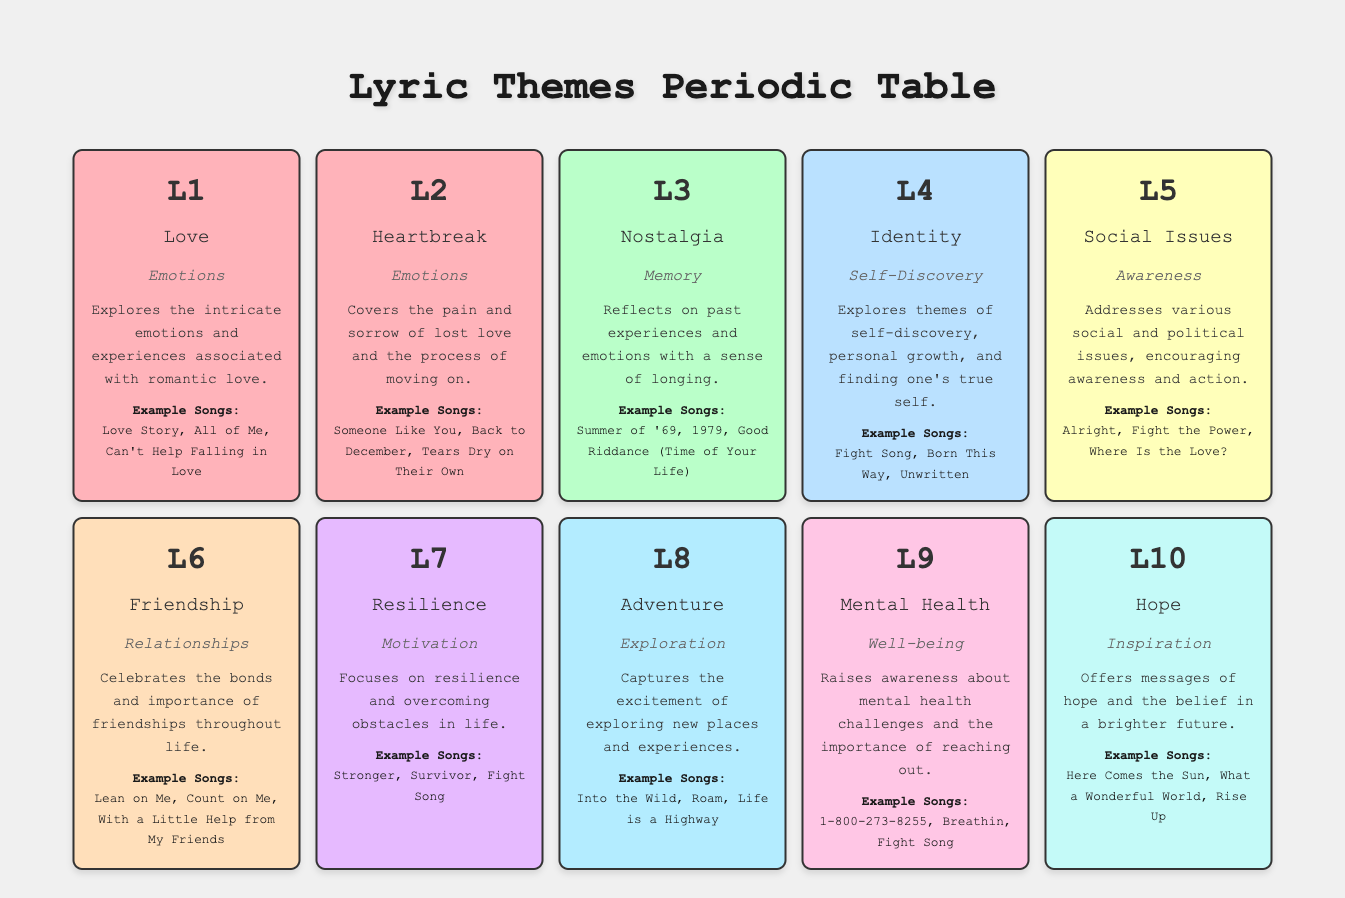What are the example songs for the theme of Identity? The table lists "Fight Song," "Born This Way," and "Unwritten" as example songs for the theme of Identity.
Answer: Fight Song, Born This Way, Unwritten Which theme addresses the pain of lost love? The theme of Heartbreak, as described in the table, specifically covers the pain and sorrow of lost love.
Answer: Heartbreak How many themes are related to emotions? There are two themes related to emotions: Love and Heartbreak, making a total of 2.
Answer: 2 Is "Lean on Me" part of the theme of Friendship? Yes, according to the table, "Lean on Me" is listed under the Friendship theme.
Answer: Yes List the example songs for the Resilience theme. The table states that the example songs for Resilience are "Stronger," "Survivor," and "Fight Song."
Answer: Stronger, Survivor, Fight Song Which themes belong to the category of Self-Discovery? The only theme categorized under Self-Discovery in the table is Identity.
Answer: Identity What is the main focus of the theme of Adventure? The Adventure theme focuses on capturing the excitement of exploring new places and experiences.
Answer: Exploring new places and experiences If you combine the example songs from both Love and Heartbreak, how many unique songs are there? The example songs for Love are "Love Story," "All of Me," "Can't Help Falling in Love," while for Heartbreak, they are "Someone Like You," "Back to December," and "Tears Dry on Their Own." Listing them gives us 6 unique songs in total.
Answer: 6 Which theme includes songs that raise awareness about mental health challenges? The table indicates that the Mental Health theme specifically raises awareness regarding mental health challenges.
Answer: Mental Health 